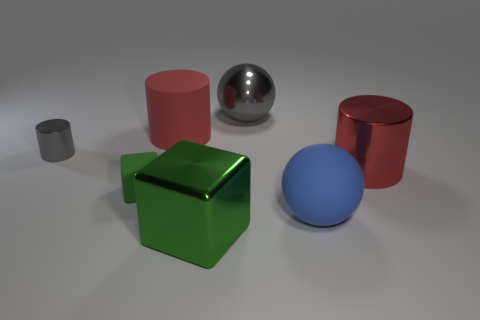There is a thing that is the same color as the big matte cylinder; what shape is it?
Your answer should be compact. Cylinder. There is another rubber cube that is the same color as the large block; what is its size?
Your answer should be very brief. Small. Does the big shiny cylinder have the same color as the rubber thing to the right of the green metal cube?
Offer a terse response. No. How many other objects are the same size as the blue rubber thing?
Provide a succinct answer. 4. The large metal thing behind the metallic cylinder in front of the gray shiny cylinder left of the metal sphere is what shape?
Give a very brief answer. Sphere. Is the size of the gray cylinder the same as the metallic cylinder that is on the right side of the big gray ball?
Give a very brief answer. No. There is a big object that is both on the left side of the big gray object and behind the tiny green rubber block; what is its color?
Your answer should be very brief. Red. How many other things are the same shape as the small gray object?
Your response must be concise. 2. Does the big matte thing right of the large rubber cylinder have the same color as the large cylinder that is on the left side of the blue matte sphere?
Provide a succinct answer. No. There is a cylinder in front of the gray shiny cylinder; does it have the same size as the sphere in front of the gray sphere?
Give a very brief answer. Yes. 